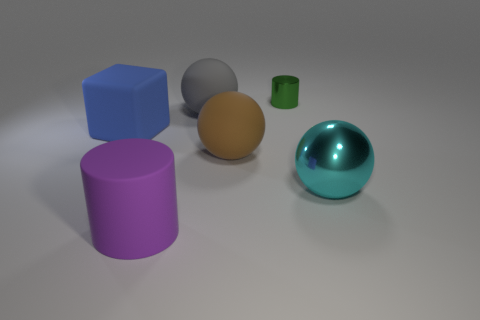Add 2 large cyan things. How many objects exist? 8 Subtract all cylinders. How many objects are left? 4 Subtract all brown spheres. Subtract all green objects. How many objects are left? 4 Add 1 matte cylinders. How many matte cylinders are left? 2 Add 5 blue matte objects. How many blue matte objects exist? 6 Subtract 0 cyan cubes. How many objects are left? 6 